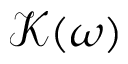<formula> <loc_0><loc_0><loc_500><loc_500>\mathcal { K } ( \omega )</formula> 